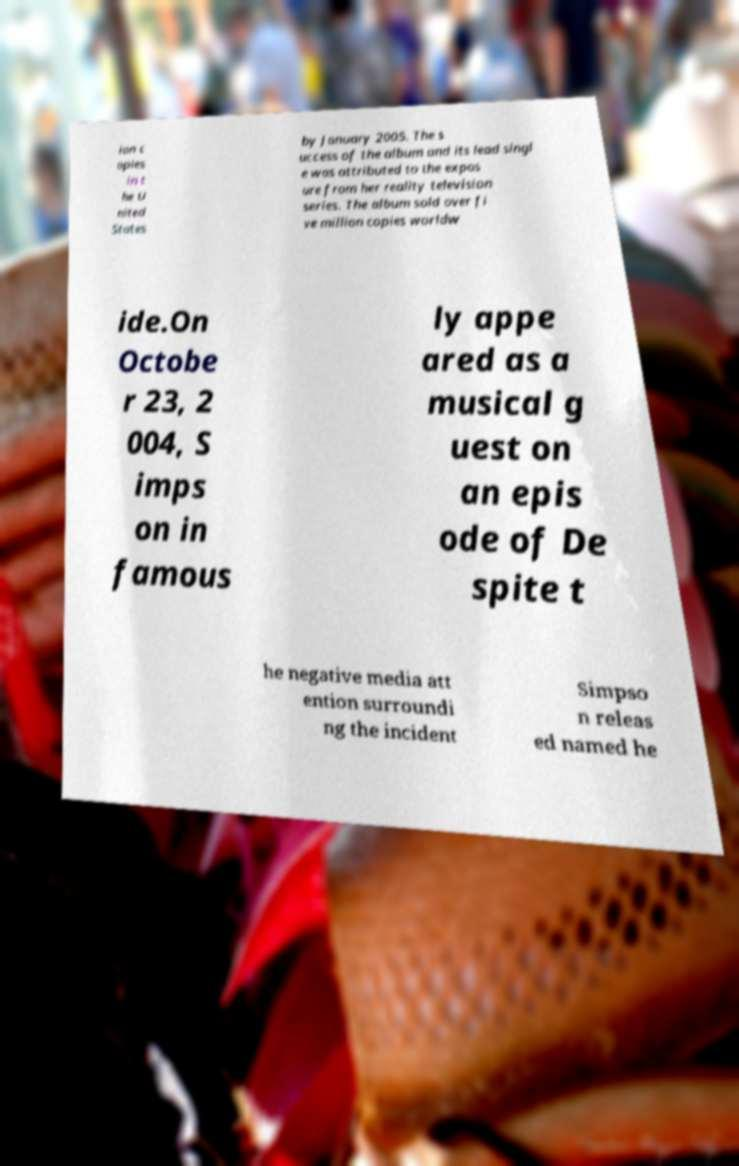Can you accurately transcribe the text from the provided image for me? ion c opies in t he U nited States by January 2005. The s uccess of the album and its lead singl e was attributed to the expos ure from her reality television series. The album sold over fi ve million copies worldw ide.On Octobe r 23, 2 004, S imps on in famous ly appe ared as a musical g uest on an epis ode of De spite t he negative media att ention surroundi ng the incident Simpso n releas ed named he 